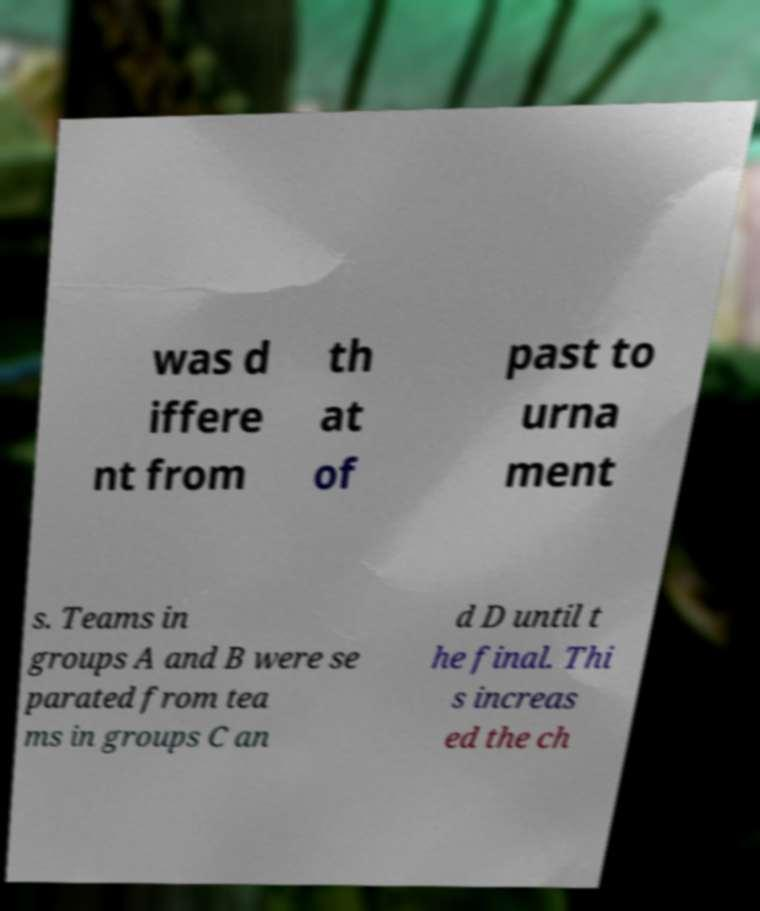Can you accurately transcribe the text from the provided image for me? was d iffere nt from th at of past to urna ment s. Teams in groups A and B were se parated from tea ms in groups C an d D until t he final. Thi s increas ed the ch 